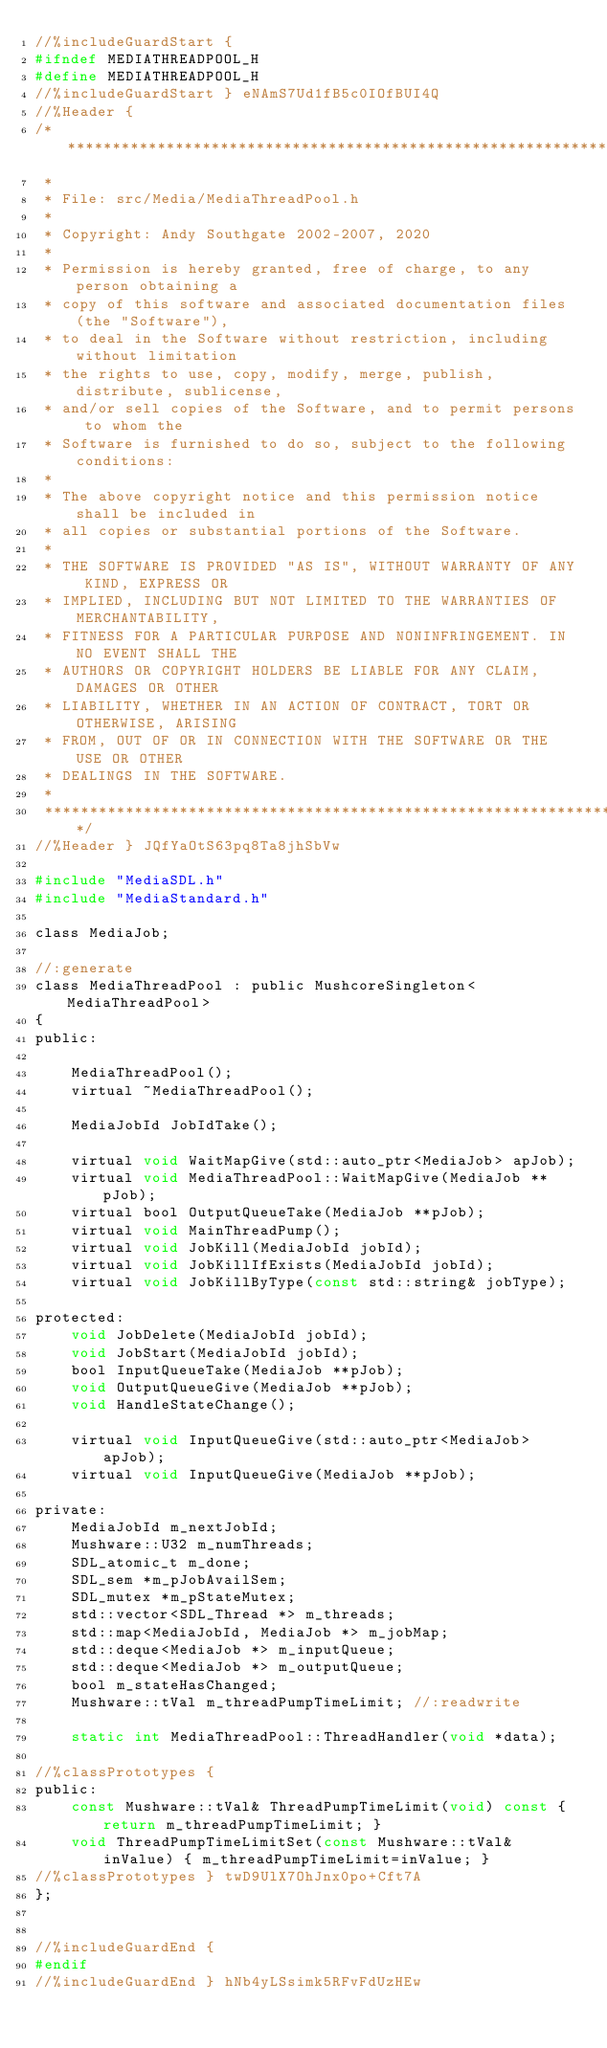Convert code to text. <code><loc_0><loc_0><loc_500><loc_500><_C_>//%includeGuardStart {
#ifndef MEDIATHREADPOOL_H
#define MEDIATHREADPOOL_H
//%includeGuardStart } eNAmS7Ud1fB5c0IOfBUI4Q
//%Header {
/*****************************************************************************
 *
 * File: src/Media/MediaThreadPool.h
 *
 * Copyright: Andy Southgate 2002-2007, 2020
 *
 * Permission is hereby granted, free of charge, to any person obtaining a
 * copy of this software and associated documentation files (the "Software"),
 * to deal in the Software without restriction, including without limitation
 * the rights to use, copy, modify, merge, publish, distribute, sublicense,
 * and/or sell copies of the Software, and to permit persons to whom the
 * Software is furnished to do so, subject to the following conditions:
 *
 * The above copyright notice and this permission notice shall be included in
 * all copies or substantial portions of the Software.
 *
 * THE SOFTWARE IS PROVIDED "AS IS", WITHOUT WARRANTY OF ANY KIND, EXPRESS OR
 * IMPLIED, INCLUDING BUT NOT LIMITED TO THE WARRANTIES OF MERCHANTABILITY,
 * FITNESS FOR A PARTICULAR PURPOSE AND NONINFRINGEMENT. IN NO EVENT SHALL THE
 * AUTHORS OR COPYRIGHT HOLDERS BE LIABLE FOR ANY CLAIM, DAMAGES OR OTHER
 * LIABILITY, WHETHER IN AN ACTION OF CONTRACT, TORT OR OTHERWISE, ARISING
 * FROM, OUT OF OR IN CONNECTION WITH THE SOFTWARE OR THE USE OR OTHER
 * DEALINGS IN THE SOFTWARE.
 *
 ****************************************************************************/
//%Header } JQfYaOtS63pq8Ta8jhSbVw

#include "MediaSDL.h"
#include "MediaStandard.h"

class MediaJob;

//:generate
class MediaThreadPool : public MushcoreSingleton<MediaThreadPool>
{
public:

    MediaThreadPool();
    virtual ~MediaThreadPool();

    MediaJobId JobIdTake();

    virtual void WaitMapGive(std::auto_ptr<MediaJob> apJob);
    virtual void MediaThreadPool::WaitMapGive(MediaJob **pJob);
    virtual bool OutputQueueTake(MediaJob **pJob);
    virtual void MainThreadPump();
    virtual void JobKill(MediaJobId jobId);
    virtual void JobKillIfExists(MediaJobId jobId);
    virtual void JobKillByType(const std::string& jobType);

protected:
    void JobDelete(MediaJobId jobId);
    void JobStart(MediaJobId jobId);
    bool InputQueueTake(MediaJob **pJob);
    void OutputQueueGive(MediaJob **pJob);
    void HandleStateChange();

    virtual void InputQueueGive(std::auto_ptr<MediaJob> apJob);
    virtual void InputQueueGive(MediaJob **pJob);

private:
    MediaJobId m_nextJobId;
    Mushware::U32 m_numThreads;
    SDL_atomic_t m_done;
    SDL_sem *m_pJobAvailSem;
    SDL_mutex *m_pStateMutex;
    std::vector<SDL_Thread *> m_threads;
    std::map<MediaJobId, MediaJob *> m_jobMap;
    std::deque<MediaJob *> m_inputQueue;
    std::deque<MediaJob *> m_outputQueue;
    bool m_stateHasChanged;
    Mushware::tVal m_threadPumpTimeLimit; //:readwrite

    static int MediaThreadPool::ThreadHandler(void *data);

//%classPrototypes {
public:
    const Mushware::tVal& ThreadPumpTimeLimit(void) const { return m_threadPumpTimeLimit; }
    void ThreadPumpTimeLimitSet(const Mushware::tVal& inValue) { m_threadPumpTimeLimit=inValue; }
//%classPrototypes } twD9UlX7OhJnx0po+Cft7A
};


//%includeGuardEnd {
#endif
//%includeGuardEnd } hNb4yLSsimk5RFvFdUzHEw
</code> 